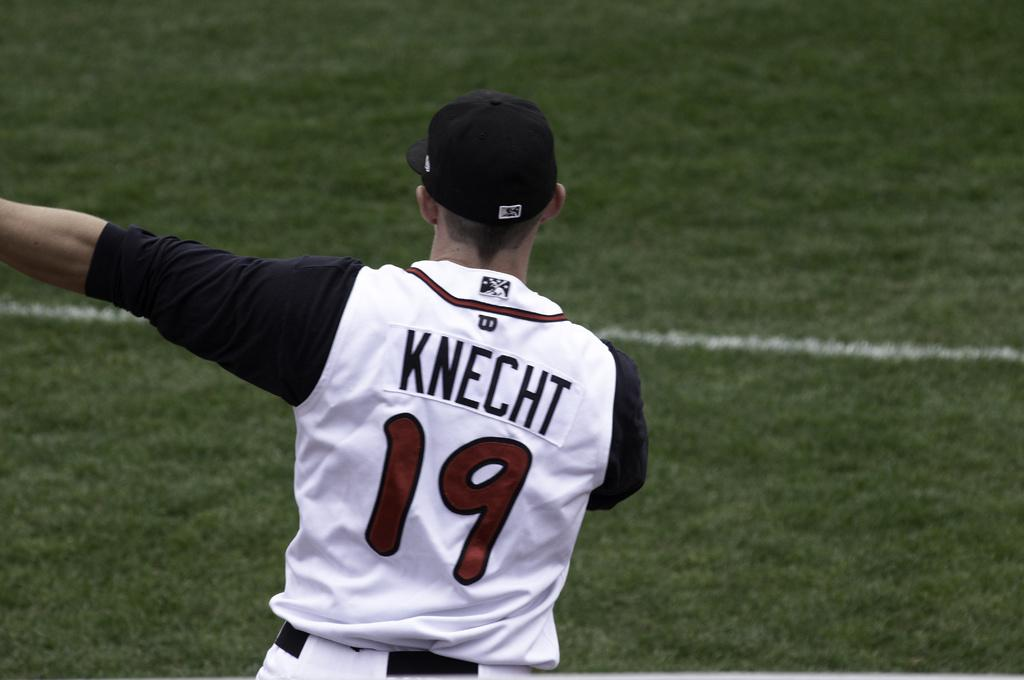Provide a one-sentence caption for the provided image. Major League Baseball player Knecht gestures to the left. 